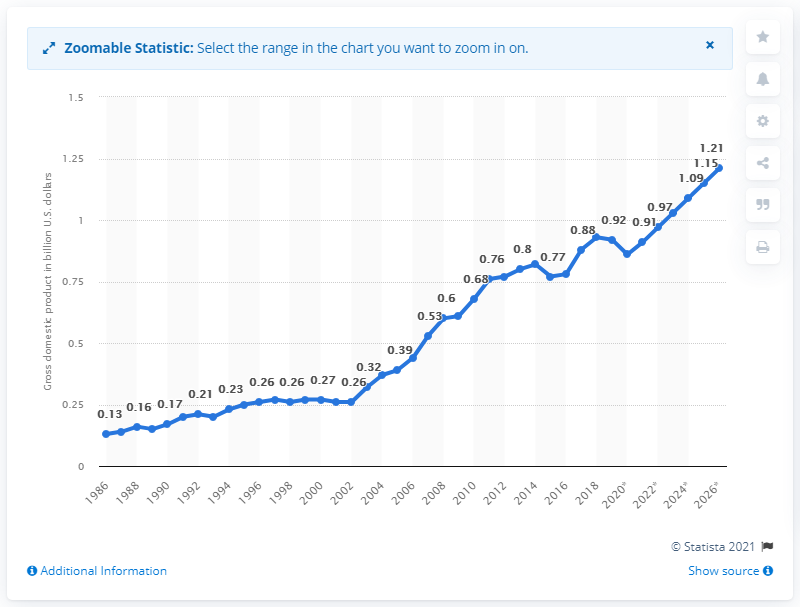Specify some key components in this picture. In 2018, the gross domestic product of Vanuatu was approximately $0.93 billion in U.S. dollars. 